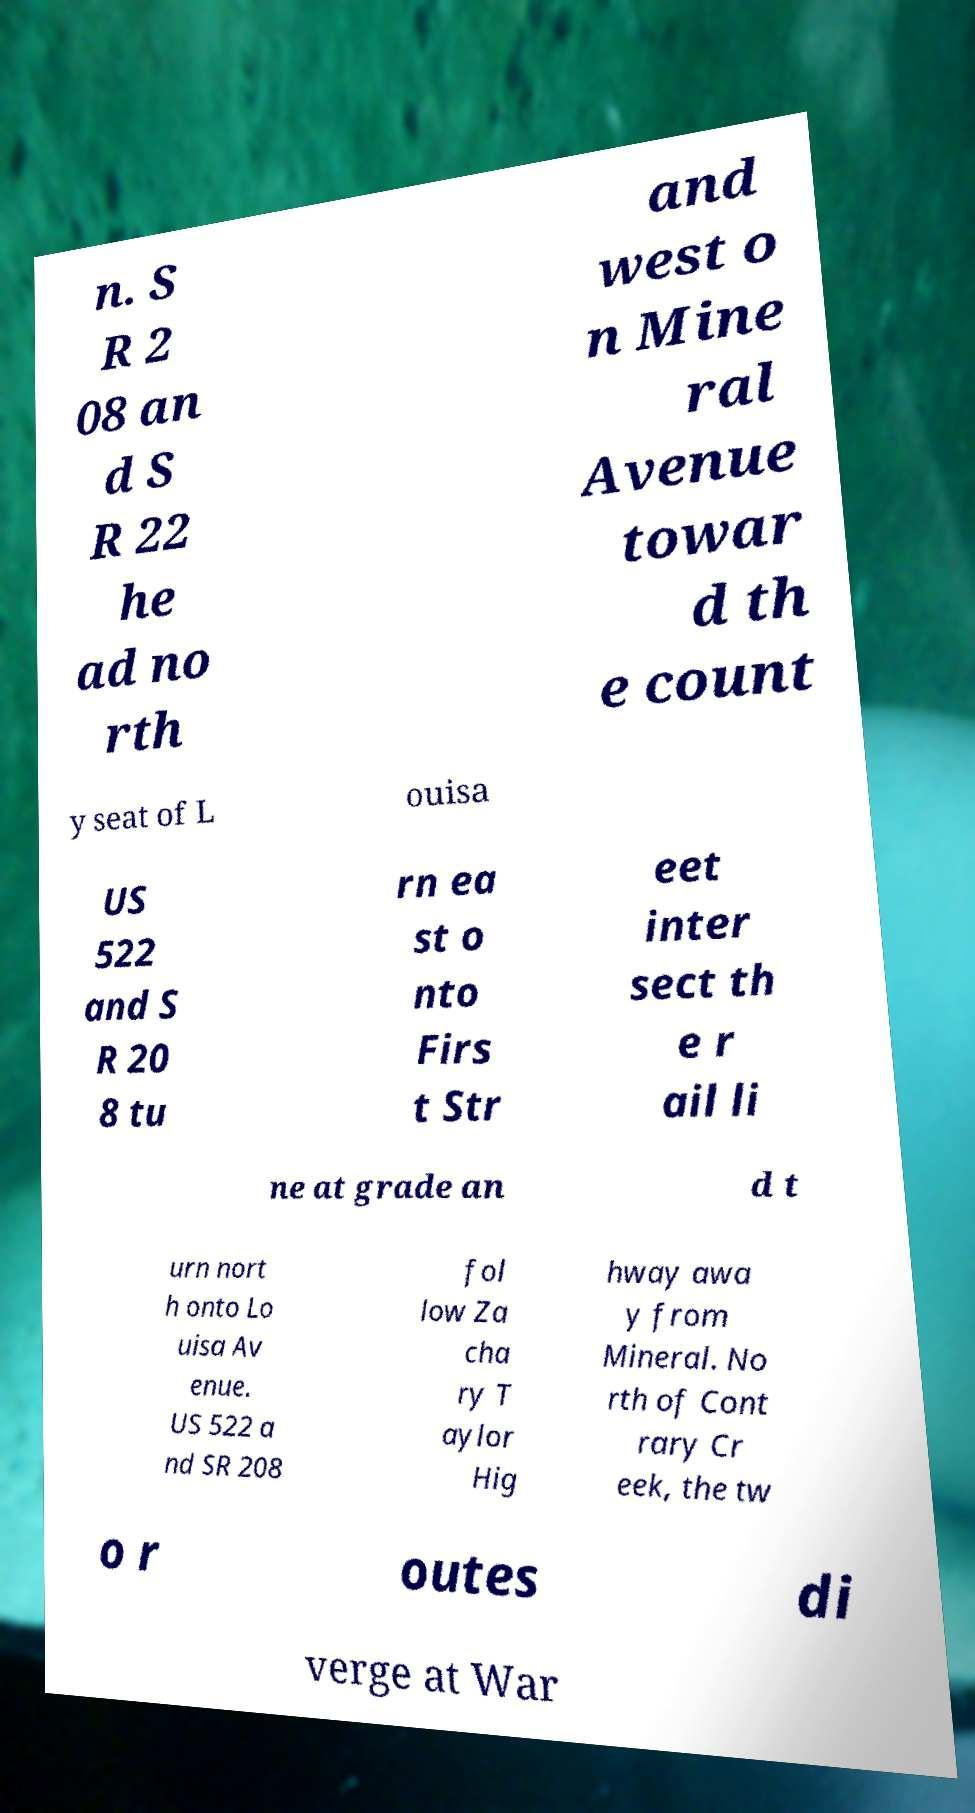I need the written content from this picture converted into text. Can you do that? n. S R 2 08 an d S R 22 he ad no rth and west o n Mine ral Avenue towar d th e count y seat of L ouisa US 522 and S R 20 8 tu rn ea st o nto Firs t Str eet inter sect th e r ail li ne at grade an d t urn nort h onto Lo uisa Av enue. US 522 a nd SR 208 fol low Za cha ry T aylor Hig hway awa y from Mineral. No rth of Cont rary Cr eek, the tw o r outes di verge at War 